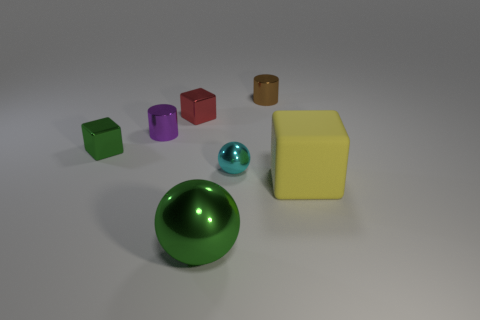Subtract all tiny blocks. How many blocks are left? 1 Add 2 blue metal things. How many objects exist? 9 Subtract 2 blocks. How many blocks are left? 1 Subtract all red cubes. How many cubes are left? 2 Subtract all brown cubes. How many purple cylinders are left? 1 Add 7 big green metallic objects. How many big green metallic objects are left? 8 Add 2 green metal blocks. How many green metal blocks exist? 3 Subtract 0 red balls. How many objects are left? 7 Subtract all blocks. How many objects are left? 4 Subtract all green spheres. Subtract all red cylinders. How many spheres are left? 1 